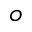Convert formula to latex. <formula><loc_0><loc_0><loc_500><loc_500>o</formula> 